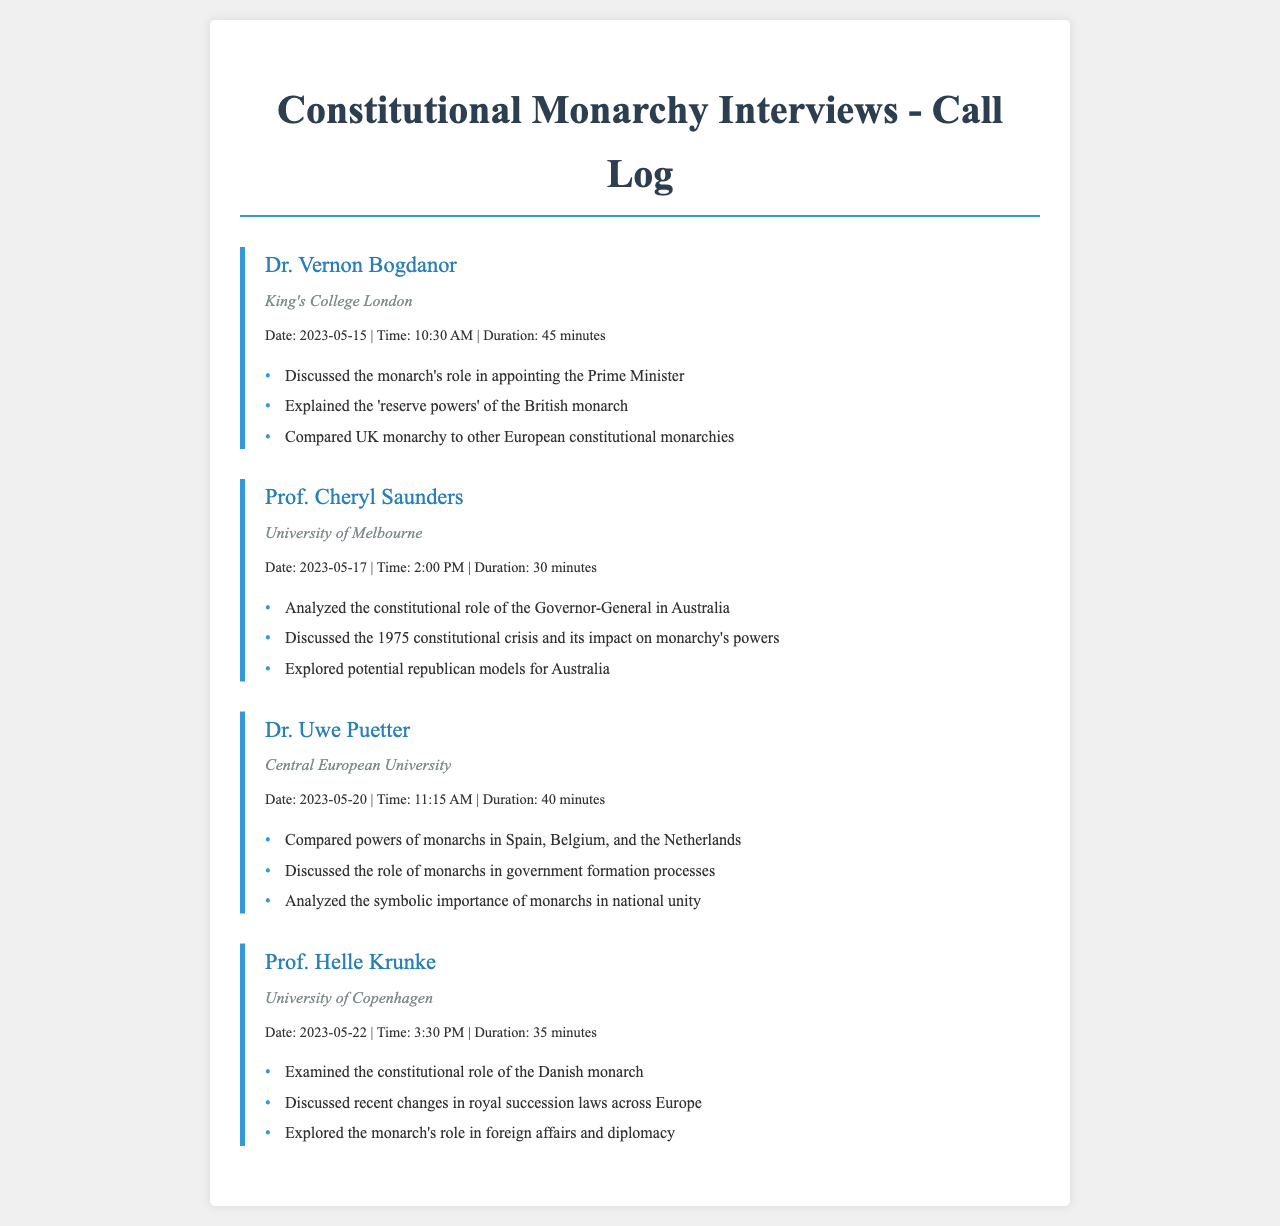What is the name of the expert from King's College London? The document lists Dr. Vernon Bogdanor as the expert from King's College London.
Answer: Dr. Vernon Bogdanor On what date was the interview with Prof. Cheryl Saunders conducted? The call log indicates that the interview with Prof. Cheryl Saunders took place on May 17, 2023.
Answer: May 17, 2023 How long did the interview with Dr. Uwe Puetter last? According to the call details, the conversation with Dr. Uwe Puetter had a duration of 40 minutes.
Answer: 40 minutes What major event did Prof. Cheryl Saunders discuss regarding Australia's monarchy? The interview mentions the discussion of the 1975 constitutional crisis and its impact on monarchy's powers.
Answer: 1975 constitutional crisis Which institution does Prof. Helle Krunke represent? The document states that Prof. Helle Krunke is associated with the University of Copenhagen.
Answer: University of Copenhagen How many experts were interviewed based on the call log? The document lists a total of four experts who were interviewed.
Answer: Four 